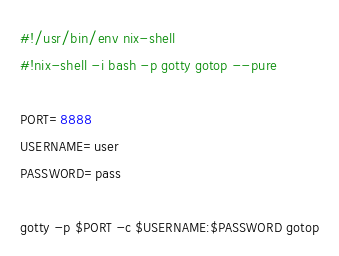Convert code to text. <code><loc_0><loc_0><loc_500><loc_500><_Bash_>#!/usr/bin/env nix-shell
#!nix-shell -i bash -p gotty gotop --pure

PORT=8888
USERNAME=user
PASSWORD=pass

gotty -p $PORT -c $USERNAME:$PASSWORD gotop
</code> 